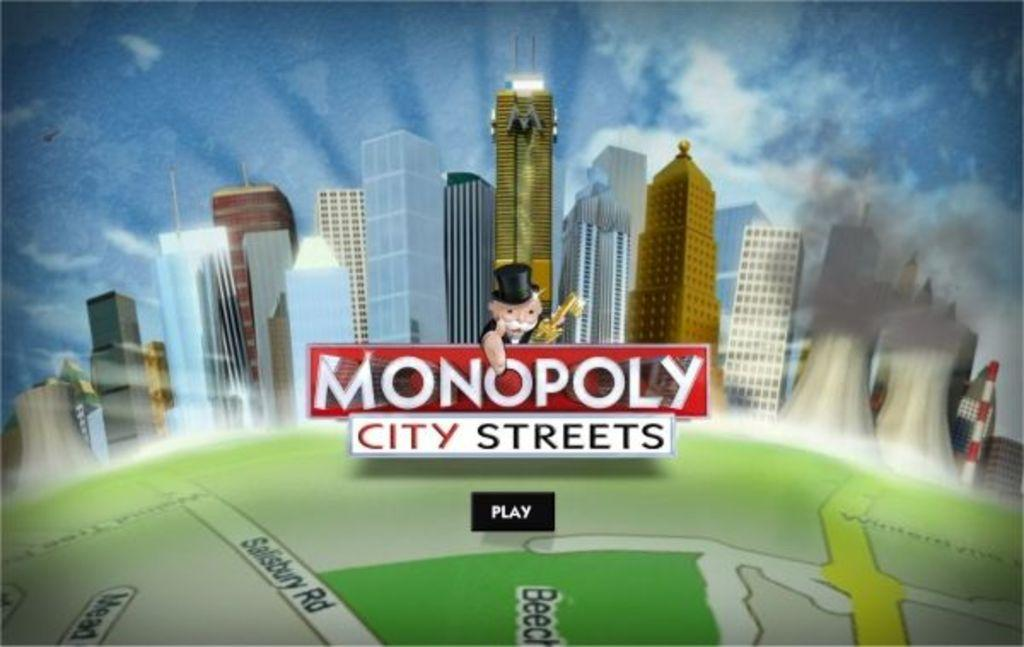What is the main subject of the picture in the image? The image contains a picture. What type of buildings can be seen in the picture? There are skyscrapers in the picture. What is visible in the sky in the picture? The sky with clouds is visible in the picture. What type of object is present in the picture that helps with navigation? There is a map in the picture. What is the person in the picture doing? A person holding a flag is present in the picture. How does the feeling of destruction manifest in the image? There is no indication of destruction or any feelings in the image; it features a picture with skyscrapers, sky with clouds, a map, and a person holding a flag. Can you tell me how many times the person jumps in the image? There is no person jumping in the image; the person is holding a flag. 